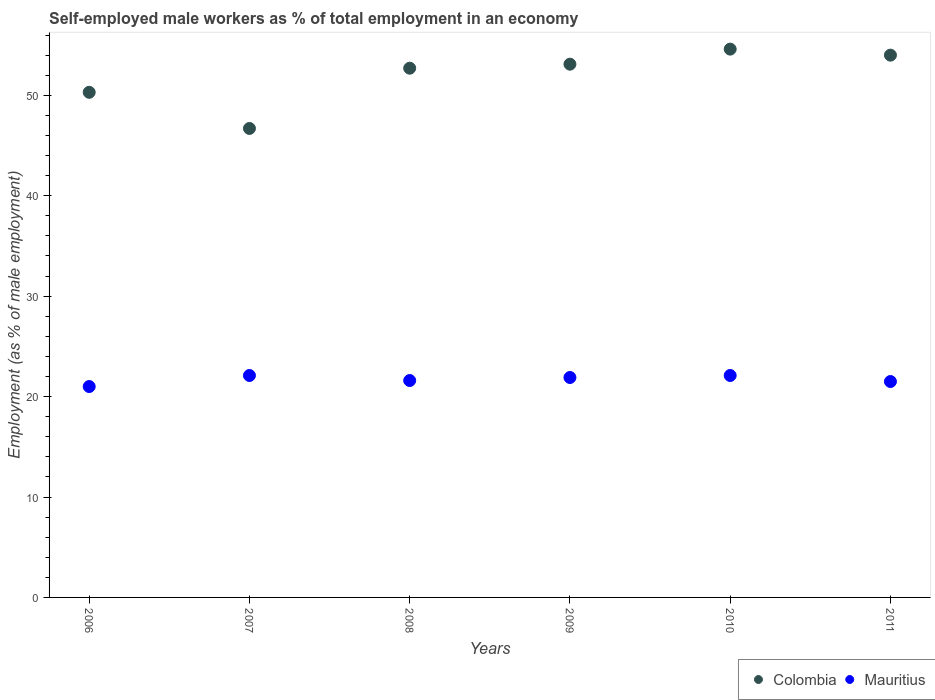Is the number of dotlines equal to the number of legend labels?
Make the answer very short. Yes. What is the percentage of self-employed male workers in Mauritius in 2010?
Offer a very short reply. 22.1. Across all years, what is the maximum percentage of self-employed male workers in Mauritius?
Make the answer very short. 22.1. Across all years, what is the minimum percentage of self-employed male workers in Colombia?
Keep it short and to the point. 46.7. In which year was the percentage of self-employed male workers in Mauritius maximum?
Provide a short and direct response. 2007. In which year was the percentage of self-employed male workers in Colombia minimum?
Offer a very short reply. 2007. What is the total percentage of self-employed male workers in Mauritius in the graph?
Provide a succinct answer. 130.2. What is the difference between the percentage of self-employed male workers in Mauritius in 2009 and that in 2011?
Your answer should be compact. 0.4. What is the difference between the percentage of self-employed male workers in Mauritius in 2006 and the percentage of self-employed male workers in Colombia in 2010?
Your answer should be very brief. -33.6. What is the average percentage of self-employed male workers in Colombia per year?
Keep it short and to the point. 51.9. In the year 2009, what is the difference between the percentage of self-employed male workers in Mauritius and percentage of self-employed male workers in Colombia?
Make the answer very short. -31.2. What is the ratio of the percentage of self-employed male workers in Mauritius in 2009 to that in 2011?
Provide a short and direct response. 1.02. What is the difference between the highest and the second highest percentage of self-employed male workers in Colombia?
Provide a short and direct response. 0.6. What is the difference between the highest and the lowest percentage of self-employed male workers in Mauritius?
Provide a short and direct response. 1.1. In how many years, is the percentage of self-employed male workers in Mauritius greater than the average percentage of self-employed male workers in Mauritius taken over all years?
Offer a very short reply. 3. Is the sum of the percentage of self-employed male workers in Mauritius in 2009 and 2010 greater than the maximum percentage of self-employed male workers in Colombia across all years?
Keep it short and to the point. No. Is the percentage of self-employed male workers in Mauritius strictly greater than the percentage of self-employed male workers in Colombia over the years?
Your response must be concise. No. Is the percentage of self-employed male workers in Colombia strictly less than the percentage of self-employed male workers in Mauritius over the years?
Offer a terse response. No. What is the difference between two consecutive major ticks on the Y-axis?
Provide a succinct answer. 10. Does the graph contain grids?
Your answer should be very brief. No. Where does the legend appear in the graph?
Your response must be concise. Bottom right. How many legend labels are there?
Offer a very short reply. 2. How are the legend labels stacked?
Your answer should be very brief. Horizontal. What is the title of the graph?
Keep it short and to the point. Self-employed male workers as % of total employment in an economy. Does "Romania" appear as one of the legend labels in the graph?
Keep it short and to the point. No. What is the label or title of the X-axis?
Ensure brevity in your answer.  Years. What is the label or title of the Y-axis?
Give a very brief answer. Employment (as % of male employment). What is the Employment (as % of male employment) in Colombia in 2006?
Provide a short and direct response. 50.3. What is the Employment (as % of male employment) in Mauritius in 2006?
Your answer should be very brief. 21. What is the Employment (as % of male employment) of Colombia in 2007?
Keep it short and to the point. 46.7. What is the Employment (as % of male employment) of Mauritius in 2007?
Keep it short and to the point. 22.1. What is the Employment (as % of male employment) in Colombia in 2008?
Your answer should be very brief. 52.7. What is the Employment (as % of male employment) of Mauritius in 2008?
Provide a short and direct response. 21.6. What is the Employment (as % of male employment) in Colombia in 2009?
Your response must be concise. 53.1. What is the Employment (as % of male employment) in Mauritius in 2009?
Keep it short and to the point. 21.9. What is the Employment (as % of male employment) in Colombia in 2010?
Your answer should be compact. 54.6. What is the Employment (as % of male employment) in Mauritius in 2010?
Your answer should be very brief. 22.1. What is the Employment (as % of male employment) in Colombia in 2011?
Your response must be concise. 54. What is the Employment (as % of male employment) in Mauritius in 2011?
Ensure brevity in your answer.  21.5. Across all years, what is the maximum Employment (as % of male employment) of Colombia?
Your answer should be compact. 54.6. Across all years, what is the maximum Employment (as % of male employment) in Mauritius?
Your response must be concise. 22.1. Across all years, what is the minimum Employment (as % of male employment) in Colombia?
Ensure brevity in your answer.  46.7. Across all years, what is the minimum Employment (as % of male employment) in Mauritius?
Your response must be concise. 21. What is the total Employment (as % of male employment) in Colombia in the graph?
Offer a very short reply. 311.4. What is the total Employment (as % of male employment) in Mauritius in the graph?
Make the answer very short. 130.2. What is the difference between the Employment (as % of male employment) in Colombia in 2006 and that in 2007?
Your response must be concise. 3.6. What is the difference between the Employment (as % of male employment) of Colombia in 2006 and that in 2009?
Keep it short and to the point. -2.8. What is the difference between the Employment (as % of male employment) in Colombia in 2006 and that in 2010?
Offer a terse response. -4.3. What is the difference between the Employment (as % of male employment) in Colombia in 2006 and that in 2011?
Your answer should be very brief. -3.7. What is the difference between the Employment (as % of male employment) in Mauritius in 2007 and that in 2008?
Your answer should be compact. 0.5. What is the difference between the Employment (as % of male employment) of Colombia in 2007 and that in 2010?
Offer a terse response. -7.9. What is the difference between the Employment (as % of male employment) of Colombia in 2007 and that in 2011?
Your answer should be compact. -7.3. What is the difference between the Employment (as % of male employment) in Colombia in 2008 and that in 2009?
Make the answer very short. -0.4. What is the difference between the Employment (as % of male employment) of Mauritius in 2008 and that in 2009?
Your answer should be compact. -0.3. What is the difference between the Employment (as % of male employment) in Mauritius in 2008 and that in 2011?
Offer a terse response. 0.1. What is the difference between the Employment (as % of male employment) of Mauritius in 2009 and that in 2011?
Provide a short and direct response. 0.4. What is the difference between the Employment (as % of male employment) of Colombia in 2010 and that in 2011?
Ensure brevity in your answer.  0.6. What is the difference between the Employment (as % of male employment) in Colombia in 2006 and the Employment (as % of male employment) in Mauritius in 2007?
Provide a short and direct response. 28.2. What is the difference between the Employment (as % of male employment) in Colombia in 2006 and the Employment (as % of male employment) in Mauritius in 2008?
Ensure brevity in your answer.  28.7. What is the difference between the Employment (as % of male employment) of Colombia in 2006 and the Employment (as % of male employment) of Mauritius in 2009?
Your answer should be very brief. 28.4. What is the difference between the Employment (as % of male employment) of Colombia in 2006 and the Employment (as % of male employment) of Mauritius in 2010?
Your answer should be very brief. 28.2. What is the difference between the Employment (as % of male employment) of Colombia in 2006 and the Employment (as % of male employment) of Mauritius in 2011?
Give a very brief answer. 28.8. What is the difference between the Employment (as % of male employment) in Colombia in 2007 and the Employment (as % of male employment) in Mauritius in 2008?
Your response must be concise. 25.1. What is the difference between the Employment (as % of male employment) in Colombia in 2007 and the Employment (as % of male employment) in Mauritius in 2009?
Keep it short and to the point. 24.8. What is the difference between the Employment (as % of male employment) in Colombia in 2007 and the Employment (as % of male employment) in Mauritius in 2010?
Ensure brevity in your answer.  24.6. What is the difference between the Employment (as % of male employment) in Colombia in 2007 and the Employment (as % of male employment) in Mauritius in 2011?
Offer a very short reply. 25.2. What is the difference between the Employment (as % of male employment) of Colombia in 2008 and the Employment (as % of male employment) of Mauritius in 2009?
Ensure brevity in your answer.  30.8. What is the difference between the Employment (as % of male employment) in Colombia in 2008 and the Employment (as % of male employment) in Mauritius in 2010?
Give a very brief answer. 30.6. What is the difference between the Employment (as % of male employment) in Colombia in 2008 and the Employment (as % of male employment) in Mauritius in 2011?
Your response must be concise. 31.2. What is the difference between the Employment (as % of male employment) in Colombia in 2009 and the Employment (as % of male employment) in Mauritius in 2010?
Ensure brevity in your answer.  31. What is the difference between the Employment (as % of male employment) of Colombia in 2009 and the Employment (as % of male employment) of Mauritius in 2011?
Provide a short and direct response. 31.6. What is the difference between the Employment (as % of male employment) of Colombia in 2010 and the Employment (as % of male employment) of Mauritius in 2011?
Your answer should be very brief. 33.1. What is the average Employment (as % of male employment) of Colombia per year?
Ensure brevity in your answer.  51.9. What is the average Employment (as % of male employment) in Mauritius per year?
Make the answer very short. 21.7. In the year 2006, what is the difference between the Employment (as % of male employment) of Colombia and Employment (as % of male employment) of Mauritius?
Offer a very short reply. 29.3. In the year 2007, what is the difference between the Employment (as % of male employment) of Colombia and Employment (as % of male employment) of Mauritius?
Provide a succinct answer. 24.6. In the year 2008, what is the difference between the Employment (as % of male employment) of Colombia and Employment (as % of male employment) of Mauritius?
Your answer should be very brief. 31.1. In the year 2009, what is the difference between the Employment (as % of male employment) of Colombia and Employment (as % of male employment) of Mauritius?
Offer a terse response. 31.2. In the year 2010, what is the difference between the Employment (as % of male employment) of Colombia and Employment (as % of male employment) of Mauritius?
Give a very brief answer. 32.5. In the year 2011, what is the difference between the Employment (as % of male employment) of Colombia and Employment (as % of male employment) of Mauritius?
Your answer should be compact. 32.5. What is the ratio of the Employment (as % of male employment) of Colombia in 2006 to that in 2007?
Your answer should be compact. 1.08. What is the ratio of the Employment (as % of male employment) of Mauritius in 2006 to that in 2007?
Your answer should be compact. 0.95. What is the ratio of the Employment (as % of male employment) of Colombia in 2006 to that in 2008?
Keep it short and to the point. 0.95. What is the ratio of the Employment (as % of male employment) in Mauritius in 2006 to that in 2008?
Make the answer very short. 0.97. What is the ratio of the Employment (as % of male employment) in Colombia in 2006 to that in 2009?
Make the answer very short. 0.95. What is the ratio of the Employment (as % of male employment) in Mauritius in 2006 to that in 2009?
Offer a terse response. 0.96. What is the ratio of the Employment (as % of male employment) of Colombia in 2006 to that in 2010?
Your response must be concise. 0.92. What is the ratio of the Employment (as % of male employment) of Mauritius in 2006 to that in 2010?
Provide a short and direct response. 0.95. What is the ratio of the Employment (as % of male employment) in Colombia in 2006 to that in 2011?
Ensure brevity in your answer.  0.93. What is the ratio of the Employment (as % of male employment) in Mauritius in 2006 to that in 2011?
Give a very brief answer. 0.98. What is the ratio of the Employment (as % of male employment) of Colombia in 2007 to that in 2008?
Your answer should be compact. 0.89. What is the ratio of the Employment (as % of male employment) of Mauritius in 2007 to that in 2008?
Provide a short and direct response. 1.02. What is the ratio of the Employment (as % of male employment) in Colombia in 2007 to that in 2009?
Provide a short and direct response. 0.88. What is the ratio of the Employment (as % of male employment) in Mauritius in 2007 to that in 2009?
Your answer should be very brief. 1.01. What is the ratio of the Employment (as % of male employment) of Colombia in 2007 to that in 2010?
Make the answer very short. 0.86. What is the ratio of the Employment (as % of male employment) in Mauritius in 2007 to that in 2010?
Give a very brief answer. 1. What is the ratio of the Employment (as % of male employment) of Colombia in 2007 to that in 2011?
Provide a succinct answer. 0.86. What is the ratio of the Employment (as % of male employment) of Mauritius in 2007 to that in 2011?
Provide a short and direct response. 1.03. What is the ratio of the Employment (as % of male employment) of Mauritius in 2008 to that in 2009?
Give a very brief answer. 0.99. What is the ratio of the Employment (as % of male employment) in Colombia in 2008 to that in 2010?
Keep it short and to the point. 0.97. What is the ratio of the Employment (as % of male employment) in Mauritius in 2008 to that in 2010?
Provide a succinct answer. 0.98. What is the ratio of the Employment (as % of male employment) of Colombia in 2008 to that in 2011?
Keep it short and to the point. 0.98. What is the ratio of the Employment (as % of male employment) in Mauritius in 2008 to that in 2011?
Keep it short and to the point. 1. What is the ratio of the Employment (as % of male employment) in Colombia in 2009 to that in 2010?
Give a very brief answer. 0.97. What is the ratio of the Employment (as % of male employment) of Mauritius in 2009 to that in 2010?
Provide a succinct answer. 0.99. What is the ratio of the Employment (as % of male employment) of Colombia in 2009 to that in 2011?
Make the answer very short. 0.98. What is the ratio of the Employment (as % of male employment) of Mauritius in 2009 to that in 2011?
Your answer should be compact. 1.02. What is the ratio of the Employment (as % of male employment) of Colombia in 2010 to that in 2011?
Provide a succinct answer. 1.01. What is the ratio of the Employment (as % of male employment) in Mauritius in 2010 to that in 2011?
Offer a terse response. 1.03. What is the difference between the highest and the second highest Employment (as % of male employment) in Colombia?
Offer a very short reply. 0.6. What is the difference between the highest and the second highest Employment (as % of male employment) in Mauritius?
Your answer should be compact. 0. What is the difference between the highest and the lowest Employment (as % of male employment) in Colombia?
Provide a succinct answer. 7.9. 